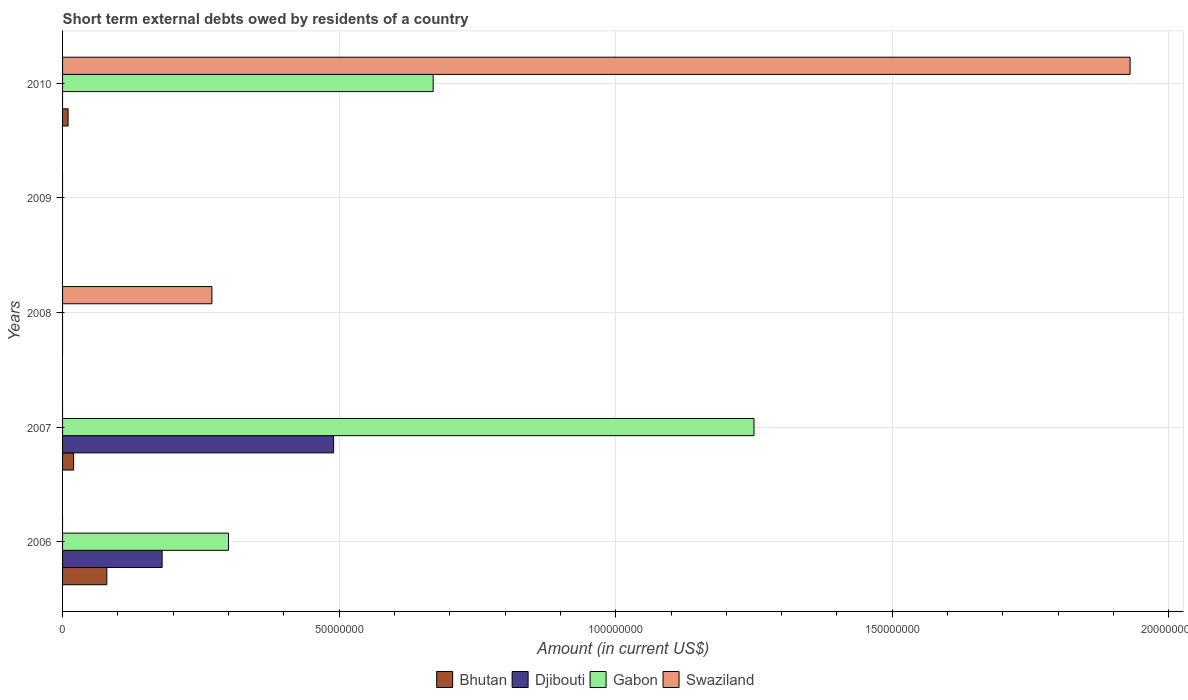How many bars are there on the 5th tick from the bottom?
Your answer should be very brief. 3. What is the label of the 4th group of bars from the top?
Give a very brief answer. 2007. In how many cases, is the number of bars for a given year not equal to the number of legend labels?
Provide a short and direct response. 5. Across all years, what is the maximum amount of short-term external debts owed by residents in Swaziland?
Your answer should be compact. 1.93e+08. Across all years, what is the minimum amount of short-term external debts owed by residents in Djibouti?
Provide a short and direct response. 0. In which year was the amount of short-term external debts owed by residents in Djibouti maximum?
Offer a terse response. 2007. What is the total amount of short-term external debts owed by residents in Swaziland in the graph?
Make the answer very short. 2.20e+08. What is the difference between the amount of short-term external debts owed by residents in Djibouti in 2006 and that in 2007?
Keep it short and to the point. -3.10e+07. What is the difference between the amount of short-term external debts owed by residents in Gabon in 2010 and the amount of short-term external debts owed by residents in Swaziland in 2007?
Offer a terse response. 6.70e+07. What is the average amount of short-term external debts owed by residents in Gabon per year?
Provide a short and direct response. 4.44e+07. In the year 2010, what is the difference between the amount of short-term external debts owed by residents in Swaziland and amount of short-term external debts owed by residents in Gabon?
Your answer should be very brief. 1.26e+08. What is the ratio of the amount of short-term external debts owed by residents in Swaziland in 2008 to that in 2010?
Provide a short and direct response. 0.14. What is the difference between the highest and the second highest amount of short-term external debts owed by residents in Gabon?
Your response must be concise. 5.80e+07. What is the difference between the highest and the lowest amount of short-term external debts owed by residents in Gabon?
Keep it short and to the point. 1.25e+08. Is the sum of the amount of short-term external debts owed by residents in Bhutan in 2006 and 2007 greater than the maximum amount of short-term external debts owed by residents in Djibouti across all years?
Your answer should be compact. No. Is it the case that in every year, the sum of the amount of short-term external debts owed by residents in Djibouti and amount of short-term external debts owed by residents in Gabon is greater than the sum of amount of short-term external debts owed by residents in Bhutan and amount of short-term external debts owed by residents in Swaziland?
Offer a terse response. No. Are all the bars in the graph horizontal?
Provide a short and direct response. Yes. Where does the legend appear in the graph?
Make the answer very short. Bottom center. How are the legend labels stacked?
Provide a succinct answer. Horizontal. What is the title of the graph?
Offer a terse response. Short term external debts owed by residents of a country. Does "Vietnam" appear as one of the legend labels in the graph?
Offer a very short reply. No. What is the Amount (in current US$) of Bhutan in 2006?
Keep it short and to the point. 8.00e+06. What is the Amount (in current US$) in Djibouti in 2006?
Provide a short and direct response. 1.80e+07. What is the Amount (in current US$) in Gabon in 2006?
Give a very brief answer. 3.00e+07. What is the Amount (in current US$) in Swaziland in 2006?
Your response must be concise. 0. What is the Amount (in current US$) of Djibouti in 2007?
Keep it short and to the point. 4.90e+07. What is the Amount (in current US$) in Gabon in 2007?
Ensure brevity in your answer.  1.25e+08. What is the Amount (in current US$) of Swaziland in 2007?
Ensure brevity in your answer.  0. What is the Amount (in current US$) in Bhutan in 2008?
Your answer should be very brief. 0. What is the Amount (in current US$) of Djibouti in 2008?
Your answer should be compact. 0. What is the Amount (in current US$) of Gabon in 2008?
Provide a succinct answer. 0. What is the Amount (in current US$) of Swaziland in 2008?
Provide a short and direct response. 2.70e+07. What is the Amount (in current US$) of Bhutan in 2009?
Your response must be concise. 0. What is the Amount (in current US$) in Djibouti in 2009?
Give a very brief answer. 0. What is the Amount (in current US$) in Gabon in 2009?
Make the answer very short. 0. What is the Amount (in current US$) of Djibouti in 2010?
Offer a very short reply. 0. What is the Amount (in current US$) of Gabon in 2010?
Your answer should be very brief. 6.70e+07. What is the Amount (in current US$) in Swaziland in 2010?
Offer a terse response. 1.93e+08. Across all years, what is the maximum Amount (in current US$) of Djibouti?
Provide a succinct answer. 4.90e+07. Across all years, what is the maximum Amount (in current US$) of Gabon?
Offer a terse response. 1.25e+08. Across all years, what is the maximum Amount (in current US$) in Swaziland?
Ensure brevity in your answer.  1.93e+08. Across all years, what is the minimum Amount (in current US$) of Gabon?
Make the answer very short. 0. Across all years, what is the minimum Amount (in current US$) in Swaziland?
Your answer should be very brief. 0. What is the total Amount (in current US$) in Bhutan in the graph?
Offer a very short reply. 1.10e+07. What is the total Amount (in current US$) in Djibouti in the graph?
Offer a very short reply. 6.70e+07. What is the total Amount (in current US$) of Gabon in the graph?
Offer a terse response. 2.22e+08. What is the total Amount (in current US$) in Swaziland in the graph?
Offer a terse response. 2.20e+08. What is the difference between the Amount (in current US$) in Djibouti in 2006 and that in 2007?
Provide a short and direct response. -3.10e+07. What is the difference between the Amount (in current US$) in Gabon in 2006 and that in 2007?
Provide a short and direct response. -9.50e+07. What is the difference between the Amount (in current US$) of Bhutan in 2006 and that in 2010?
Offer a terse response. 7.00e+06. What is the difference between the Amount (in current US$) in Gabon in 2006 and that in 2010?
Provide a short and direct response. -3.70e+07. What is the difference between the Amount (in current US$) of Gabon in 2007 and that in 2010?
Provide a succinct answer. 5.80e+07. What is the difference between the Amount (in current US$) in Swaziland in 2008 and that in 2010?
Provide a short and direct response. -1.66e+08. What is the difference between the Amount (in current US$) in Bhutan in 2006 and the Amount (in current US$) in Djibouti in 2007?
Provide a succinct answer. -4.10e+07. What is the difference between the Amount (in current US$) of Bhutan in 2006 and the Amount (in current US$) of Gabon in 2007?
Ensure brevity in your answer.  -1.17e+08. What is the difference between the Amount (in current US$) in Djibouti in 2006 and the Amount (in current US$) in Gabon in 2007?
Make the answer very short. -1.07e+08. What is the difference between the Amount (in current US$) of Bhutan in 2006 and the Amount (in current US$) of Swaziland in 2008?
Ensure brevity in your answer.  -1.90e+07. What is the difference between the Amount (in current US$) of Djibouti in 2006 and the Amount (in current US$) of Swaziland in 2008?
Offer a very short reply. -9.00e+06. What is the difference between the Amount (in current US$) of Gabon in 2006 and the Amount (in current US$) of Swaziland in 2008?
Make the answer very short. 3.00e+06. What is the difference between the Amount (in current US$) of Bhutan in 2006 and the Amount (in current US$) of Gabon in 2010?
Your answer should be compact. -5.90e+07. What is the difference between the Amount (in current US$) in Bhutan in 2006 and the Amount (in current US$) in Swaziland in 2010?
Make the answer very short. -1.85e+08. What is the difference between the Amount (in current US$) in Djibouti in 2006 and the Amount (in current US$) in Gabon in 2010?
Provide a short and direct response. -4.90e+07. What is the difference between the Amount (in current US$) in Djibouti in 2006 and the Amount (in current US$) in Swaziland in 2010?
Your answer should be very brief. -1.75e+08. What is the difference between the Amount (in current US$) in Gabon in 2006 and the Amount (in current US$) in Swaziland in 2010?
Your response must be concise. -1.63e+08. What is the difference between the Amount (in current US$) of Bhutan in 2007 and the Amount (in current US$) of Swaziland in 2008?
Your answer should be compact. -2.50e+07. What is the difference between the Amount (in current US$) in Djibouti in 2007 and the Amount (in current US$) in Swaziland in 2008?
Offer a terse response. 2.20e+07. What is the difference between the Amount (in current US$) in Gabon in 2007 and the Amount (in current US$) in Swaziland in 2008?
Give a very brief answer. 9.80e+07. What is the difference between the Amount (in current US$) of Bhutan in 2007 and the Amount (in current US$) of Gabon in 2010?
Your answer should be compact. -6.50e+07. What is the difference between the Amount (in current US$) in Bhutan in 2007 and the Amount (in current US$) in Swaziland in 2010?
Your response must be concise. -1.91e+08. What is the difference between the Amount (in current US$) in Djibouti in 2007 and the Amount (in current US$) in Gabon in 2010?
Offer a very short reply. -1.80e+07. What is the difference between the Amount (in current US$) of Djibouti in 2007 and the Amount (in current US$) of Swaziland in 2010?
Ensure brevity in your answer.  -1.44e+08. What is the difference between the Amount (in current US$) of Gabon in 2007 and the Amount (in current US$) of Swaziland in 2010?
Provide a short and direct response. -6.80e+07. What is the average Amount (in current US$) in Bhutan per year?
Provide a short and direct response. 2.20e+06. What is the average Amount (in current US$) in Djibouti per year?
Your answer should be very brief. 1.34e+07. What is the average Amount (in current US$) of Gabon per year?
Offer a very short reply. 4.44e+07. What is the average Amount (in current US$) of Swaziland per year?
Your answer should be very brief. 4.40e+07. In the year 2006, what is the difference between the Amount (in current US$) in Bhutan and Amount (in current US$) in Djibouti?
Offer a terse response. -1.00e+07. In the year 2006, what is the difference between the Amount (in current US$) of Bhutan and Amount (in current US$) of Gabon?
Provide a short and direct response. -2.20e+07. In the year 2006, what is the difference between the Amount (in current US$) of Djibouti and Amount (in current US$) of Gabon?
Give a very brief answer. -1.20e+07. In the year 2007, what is the difference between the Amount (in current US$) in Bhutan and Amount (in current US$) in Djibouti?
Offer a terse response. -4.70e+07. In the year 2007, what is the difference between the Amount (in current US$) in Bhutan and Amount (in current US$) in Gabon?
Your response must be concise. -1.23e+08. In the year 2007, what is the difference between the Amount (in current US$) in Djibouti and Amount (in current US$) in Gabon?
Offer a very short reply. -7.60e+07. In the year 2010, what is the difference between the Amount (in current US$) of Bhutan and Amount (in current US$) of Gabon?
Make the answer very short. -6.60e+07. In the year 2010, what is the difference between the Amount (in current US$) of Bhutan and Amount (in current US$) of Swaziland?
Your response must be concise. -1.92e+08. In the year 2010, what is the difference between the Amount (in current US$) of Gabon and Amount (in current US$) of Swaziland?
Make the answer very short. -1.26e+08. What is the ratio of the Amount (in current US$) in Bhutan in 2006 to that in 2007?
Your answer should be compact. 4. What is the ratio of the Amount (in current US$) in Djibouti in 2006 to that in 2007?
Provide a short and direct response. 0.37. What is the ratio of the Amount (in current US$) in Gabon in 2006 to that in 2007?
Your response must be concise. 0.24. What is the ratio of the Amount (in current US$) of Bhutan in 2006 to that in 2010?
Offer a very short reply. 8. What is the ratio of the Amount (in current US$) in Gabon in 2006 to that in 2010?
Give a very brief answer. 0.45. What is the ratio of the Amount (in current US$) in Bhutan in 2007 to that in 2010?
Ensure brevity in your answer.  2. What is the ratio of the Amount (in current US$) of Gabon in 2007 to that in 2010?
Give a very brief answer. 1.87. What is the ratio of the Amount (in current US$) in Swaziland in 2008 to that in 2010?
Make the answer very short. 0.14. What is the difference between the highest and the second highest Amount (in current US$) in Gabon?
Offer a very short reply. 5.80e+07. What is the difference between the highest and the lowest Amount (in current US$) in Djibouti?
Ensure brevity in your answer.  4.90e+07. What is the difference between the highest and the lowest Amount (in current US$) in Gabon?
Offer a very short reply. 1.25e+08. What is the difference between the highest and the lowest Amount (in current US$) in Swaziland?
Your answer should be very brief. 1.93e+08. 